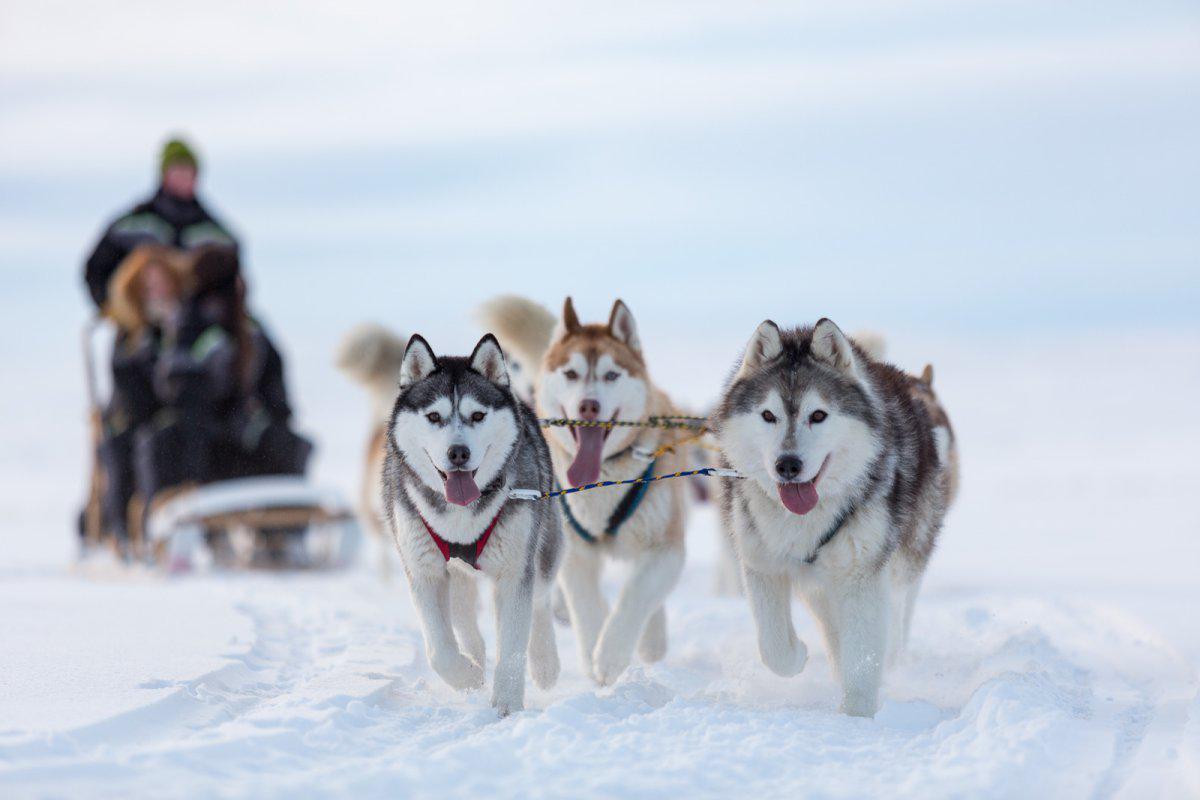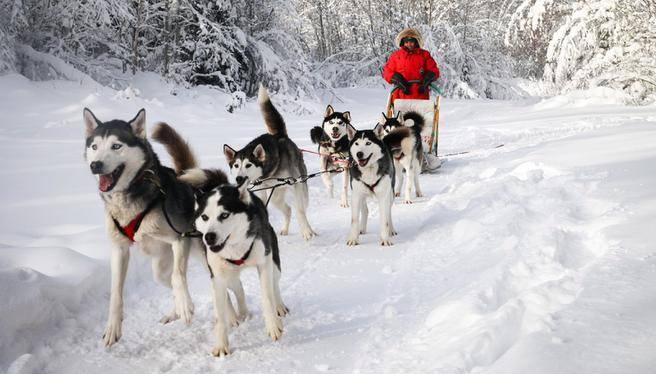The first image is the image on the left, the second image is the image on the right. Analyze the images presented: Is the assertion "In one image, mountains form the backdrop to the sled dog team." valid? Answer yes or no. No. The first image is the image on the left, the second image is the image on the right. Considering the images on both sides, is "At least one of the sleds is empty." valid? Answer yes or no. No. 